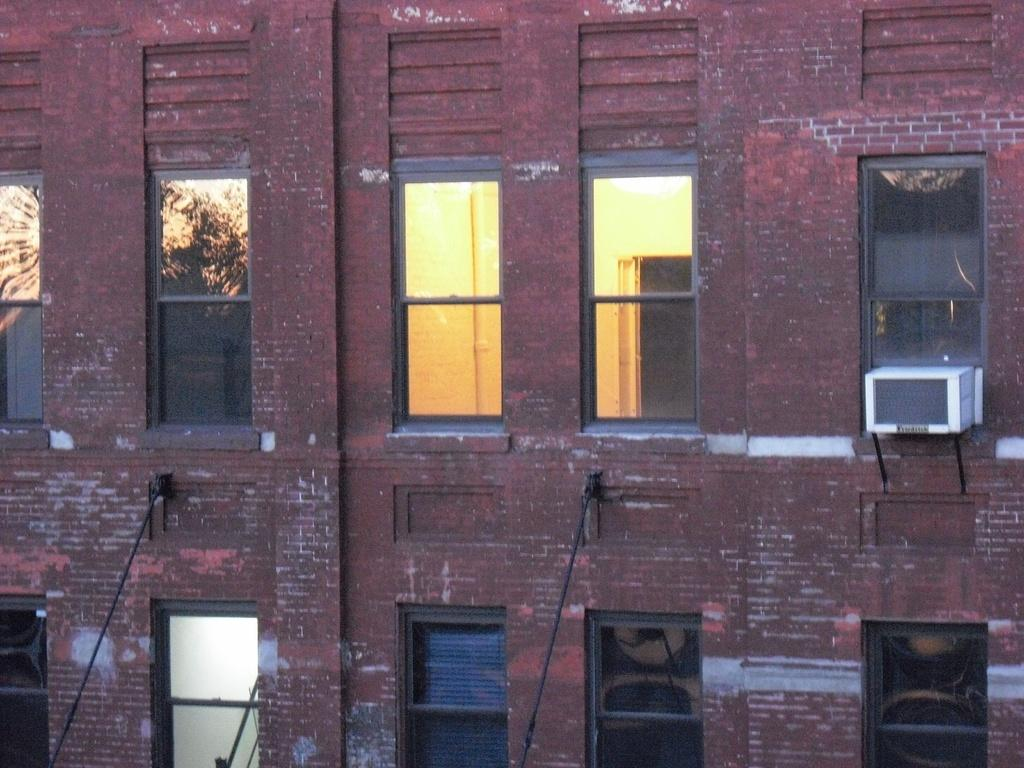What type of structure is present in the image? There is a building in the image. What feature can be observed on the building? The building has windows. What can be seen reflected on the windows? There is a reflection of the sky and a tree on the windows. What is visible inside the building? There are lights visible inside the building. What type of curtain can be seen hanging from the edge of the building in the image? There is no curtain visible hanging from the edge of the building in the image. 